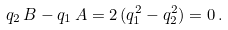<formula> <loc_0><loc_0><loc_500><loc_500>q _ { 2 } \, B - q _ { 1 } \, A = 2 \, ( q _ { 1 } ^ { 2 } - q _ { 2 } ^ { 2 } ) = 0 \, .</formula> 